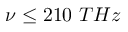Convert formula to latex. <formula><loc_0><loc_0><loc_500><loc_500>\nu \leq 2 1 0 T H z</formula> 